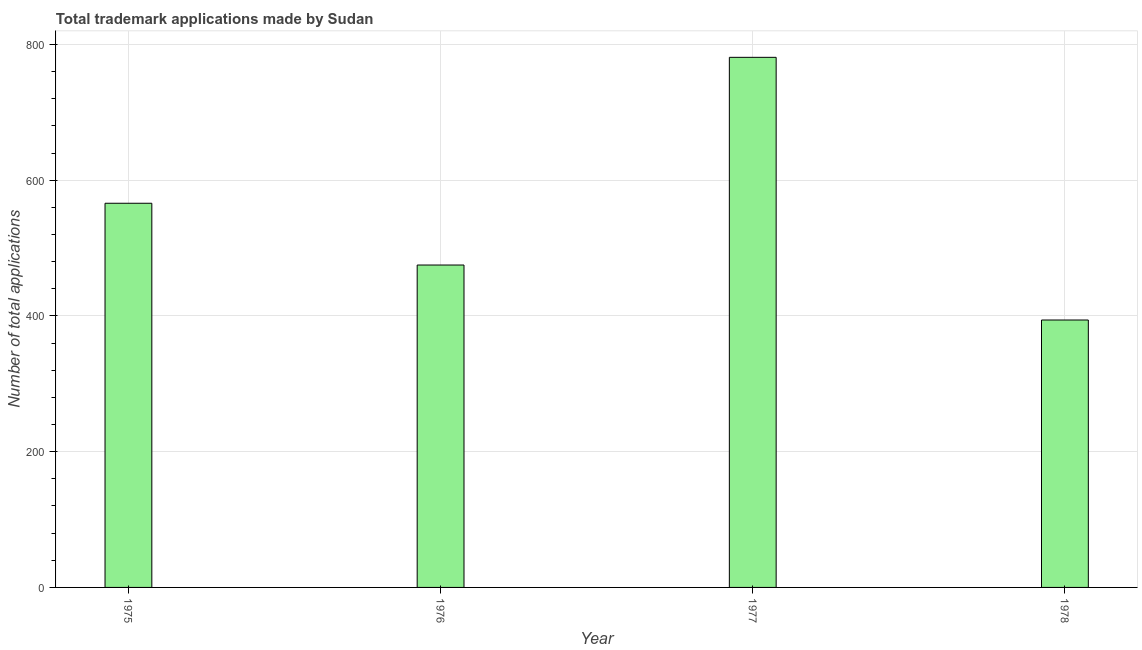Does the graph contain any zero values?
Your answer should be very brief. No. What is the title of the graph?
Make the answer very short. Total trademark applications made by Sudan. What is the label or title of the Y-axis?
Offer a very short reply. Number of total applications. What is the number of trademark applications in 1975?
Make the answer very short. 566. Across all years, what is the maximum number of trademark applications?
Offer a terse response. 781. Across all years, what is the minimum number of trademark applications?
Your answer should be compact. 394. In which year was the number of trademark applications minimum?
Offer a very short reply. 1978. What is the sum of the number of trademark applications?
Ensure brevity in your answer.  2216. What is the difference between the number of trademark applications in 1975 and 1978?
Give a very brief answer. 172. What is the average number of trademark applications per year?
Your response must be concise. 554. What is the median number of trademark applications?
Offer a very short reply. 520.5. Do a majority of the years between 1976 and 1978 (inclusive) have number of trademark applications greater than 440 ?
Offer a very short reply. Yes. What is the ratio of the number of trademark applications in 1975 to that in 1978?
Offer a very short reply. 1.44. What is the difference between the highest and the second highest number of trademark applications?
Your answer should be compact. 215. Is the sum of the number of trademark applications in 1977 and 1978 greater than the maximum number of trademark applications across all years?
Make the answer very short. Yes. What is the difference between the highest and the lowest number of trademark applications?
Your response must be concise. 387. In how many years, is the number of trademark applications greater than the average number of trademark applications taken over all years?
Ensure brevity in your answer.  2. How many bars are there?
Give a very brief answer. 4. What is the Number of total applications in 1975?
Offer a very short reply. 566. What is the Number of total applications in 1976?
Your answer should be compact. 475. What is the Number of total applications of 1977?
Offer a terse response. 781. What is the Number of total applications in 1978?
Give a very brief answer. 394. What is the difference between the Number of total applications in 1975 and 1976?
Provide a short and direct response. 91. What is the difference between the Number of total applications in 1975 and 1977?
Give a very brief answer. -215. What is the difference between the Number of total applications in 1975 and 1978?
Your answer should be compact. 172. What is the difference between the Number of total applications in 1976 and 1977?
Ensure brevity in your answer.  -306. What is the difference between the Number of total applications in 1977 and 1978?
Give a very brief answer. 387. What is the ratio of the Number of total applications in 1975 to that in 1976?
Ensure brevity in your answer.  1.19. What is the ratio of the Number of total applications in 1975 to that in 1977?
Keep it short and to the point. 0.72. What is the ratio of the Number of total applications in 1975 to that in 1978?
Keep it short and to the point. 1.44. What is the ratio of the Number of total applications in 1976 to that in 1977?
Offer a terse response. 0.61. What is the ratio of the Number of total applications in 1976 to that in 1978?
Ensure brevity in your answer.  1.21. What is the ratio of the Number of total applications in 1977 to that in 1978?
Offer a very short reply. 1.98. 